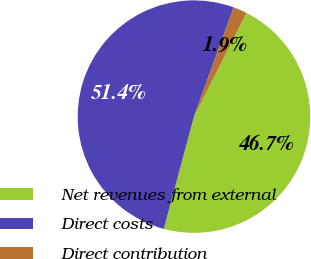<chart> <loc_0><loc_0><loc_500><loc_500><pie_chart><fcel>Net revenues from external<fcel>Direct costs<fcel>Direct contribution<nl><fcel>46.71%<fcel>51.38%<fcel>1.91%<nl></chart> 